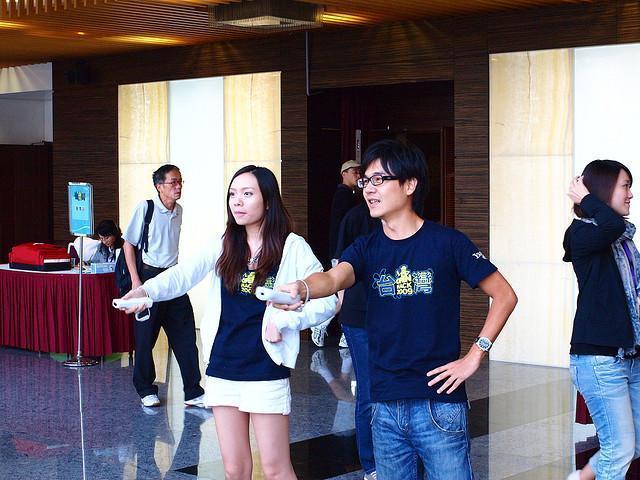How many people are visible?
Give a very brief answer. 5. How many tires on the truck are visible?
Give a very brief answer. 0. 